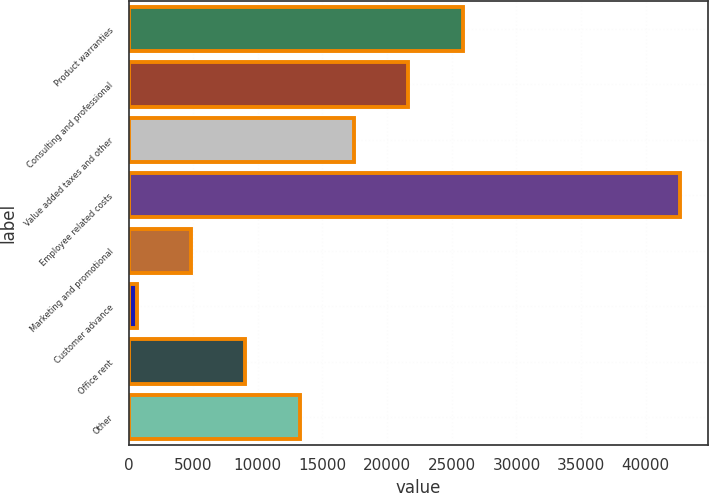Convert chart. <chart><loc_0><loc_0><loc_500><loc_500><bar_chart><fcel>Product warranties<fcel>Consulting and professional<fcel>Value added taxes and other<fcel>Employee related costs<fcel>Marketing and promotional<fcel>Customer advance<fcel>Office rent<fcel>Other<nl><fcel>25855.4<fcel>21650.5<fcel>17445.6<fcel>42675<fcel>4830.9<fcel>626<fcel>9035.8<fcel>13240.7<nl></chart> 